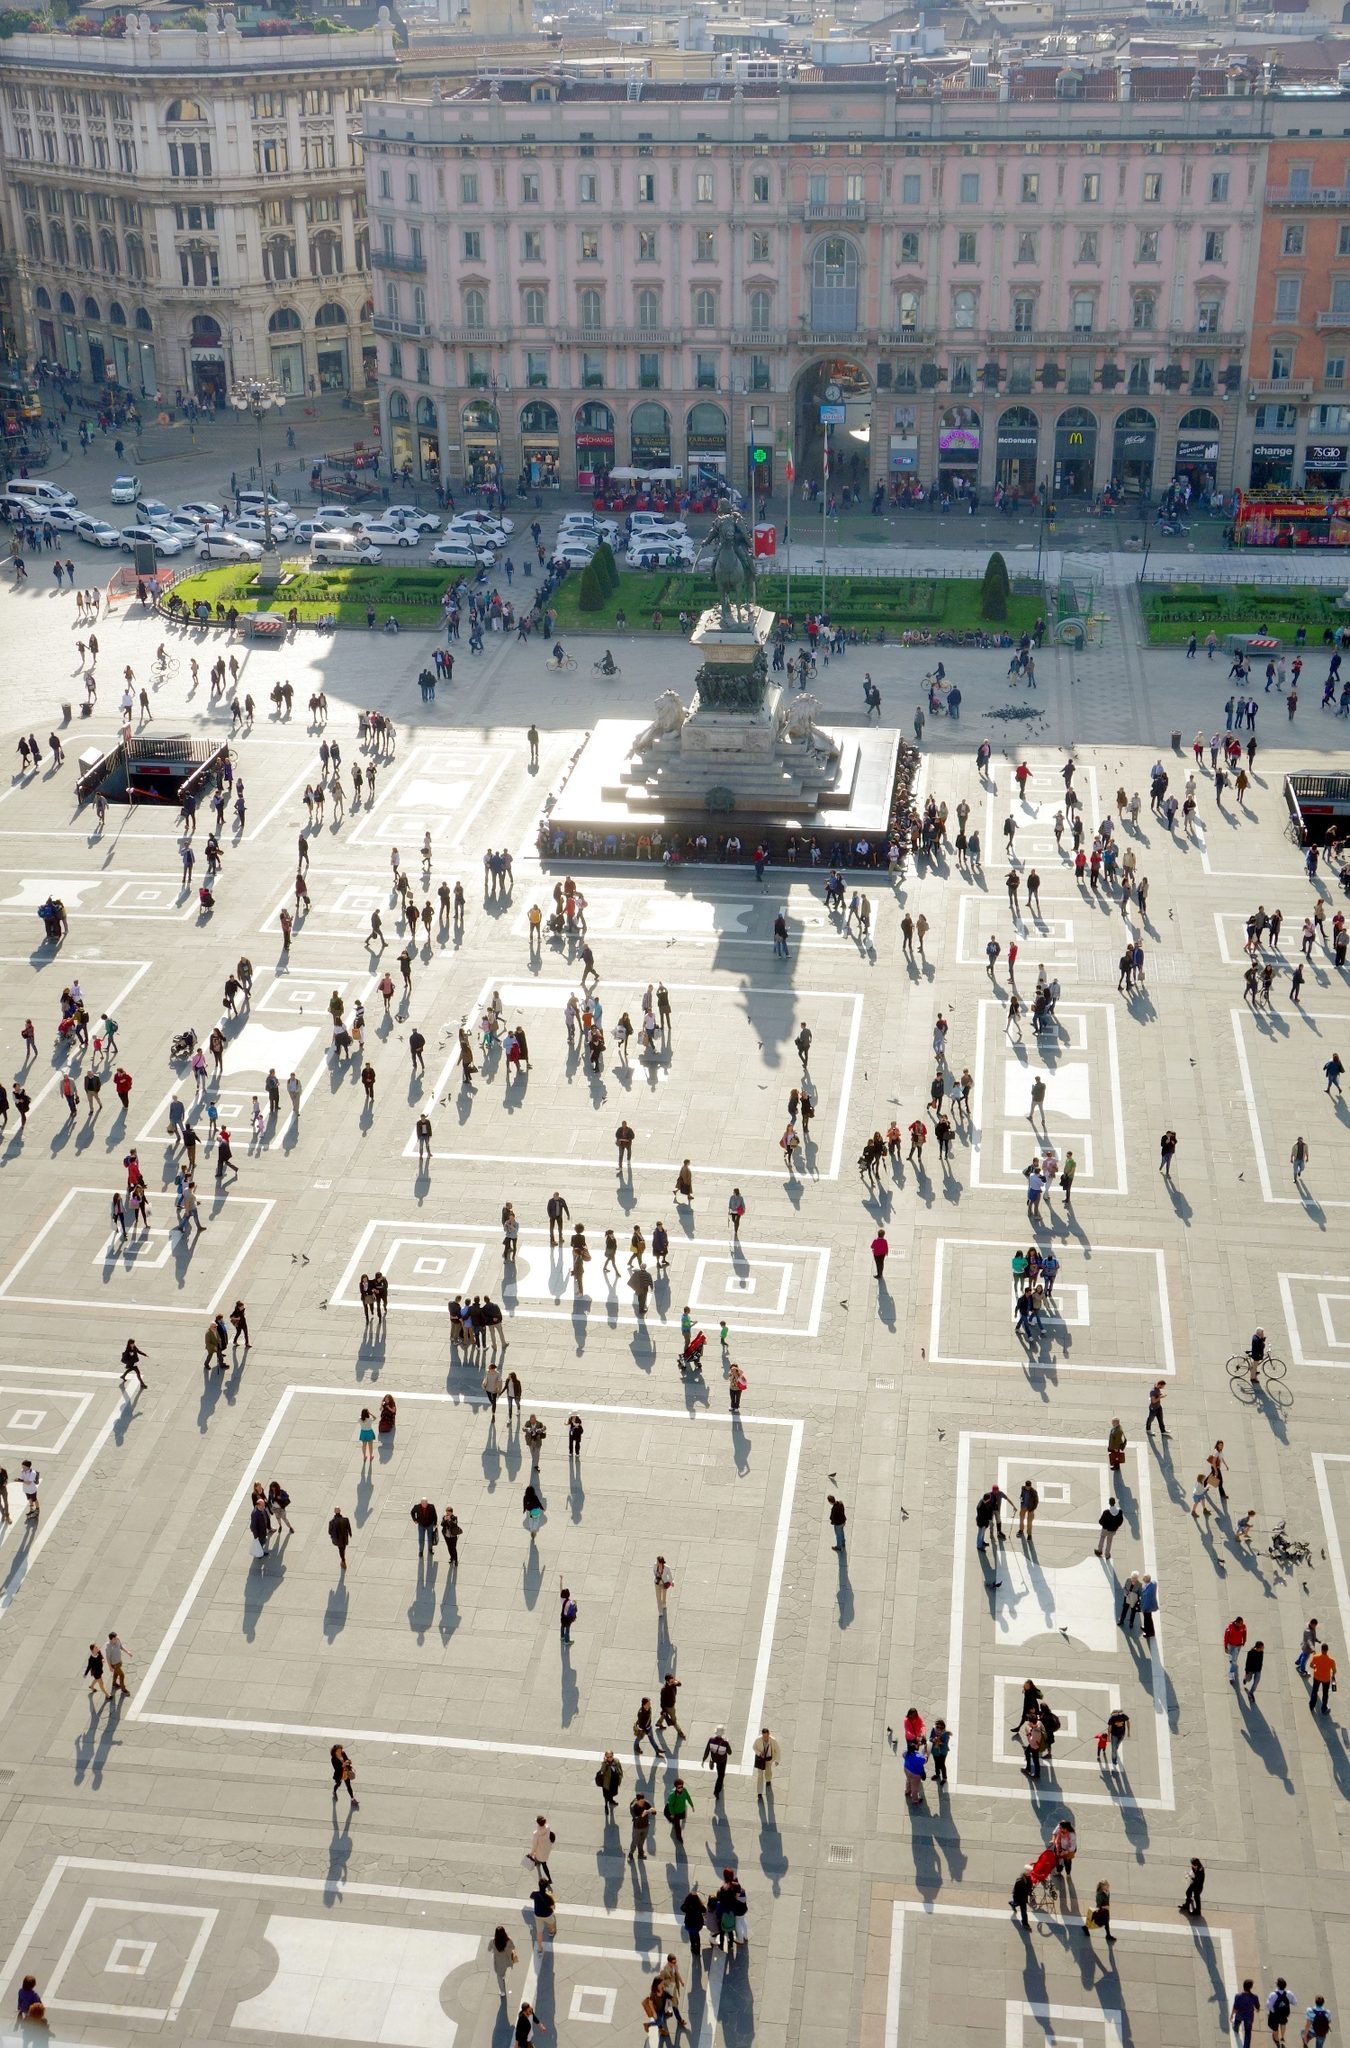Could you describe the historical significance of the buildings surrounding the Piazza del Duomo? The buildings surrounding the Piazza del Duomo are rich in historical and architectural significance. These structures reflect varying styles from different periods, showcasing the city's evolution. The Galleria Vittorio Emanuele II, visible towards the left, is one of the world’s oldest shopping malls, established in the mid-19th century and known for its impressive iron and glass structure. The long-established pink building opposite the Duomo is a fine representation of neoclassical architecture, characterized by its balanced proportions and elegant facade. The collective architecture captures Milan's history and development as a cultural and economic hub over the centuries. 